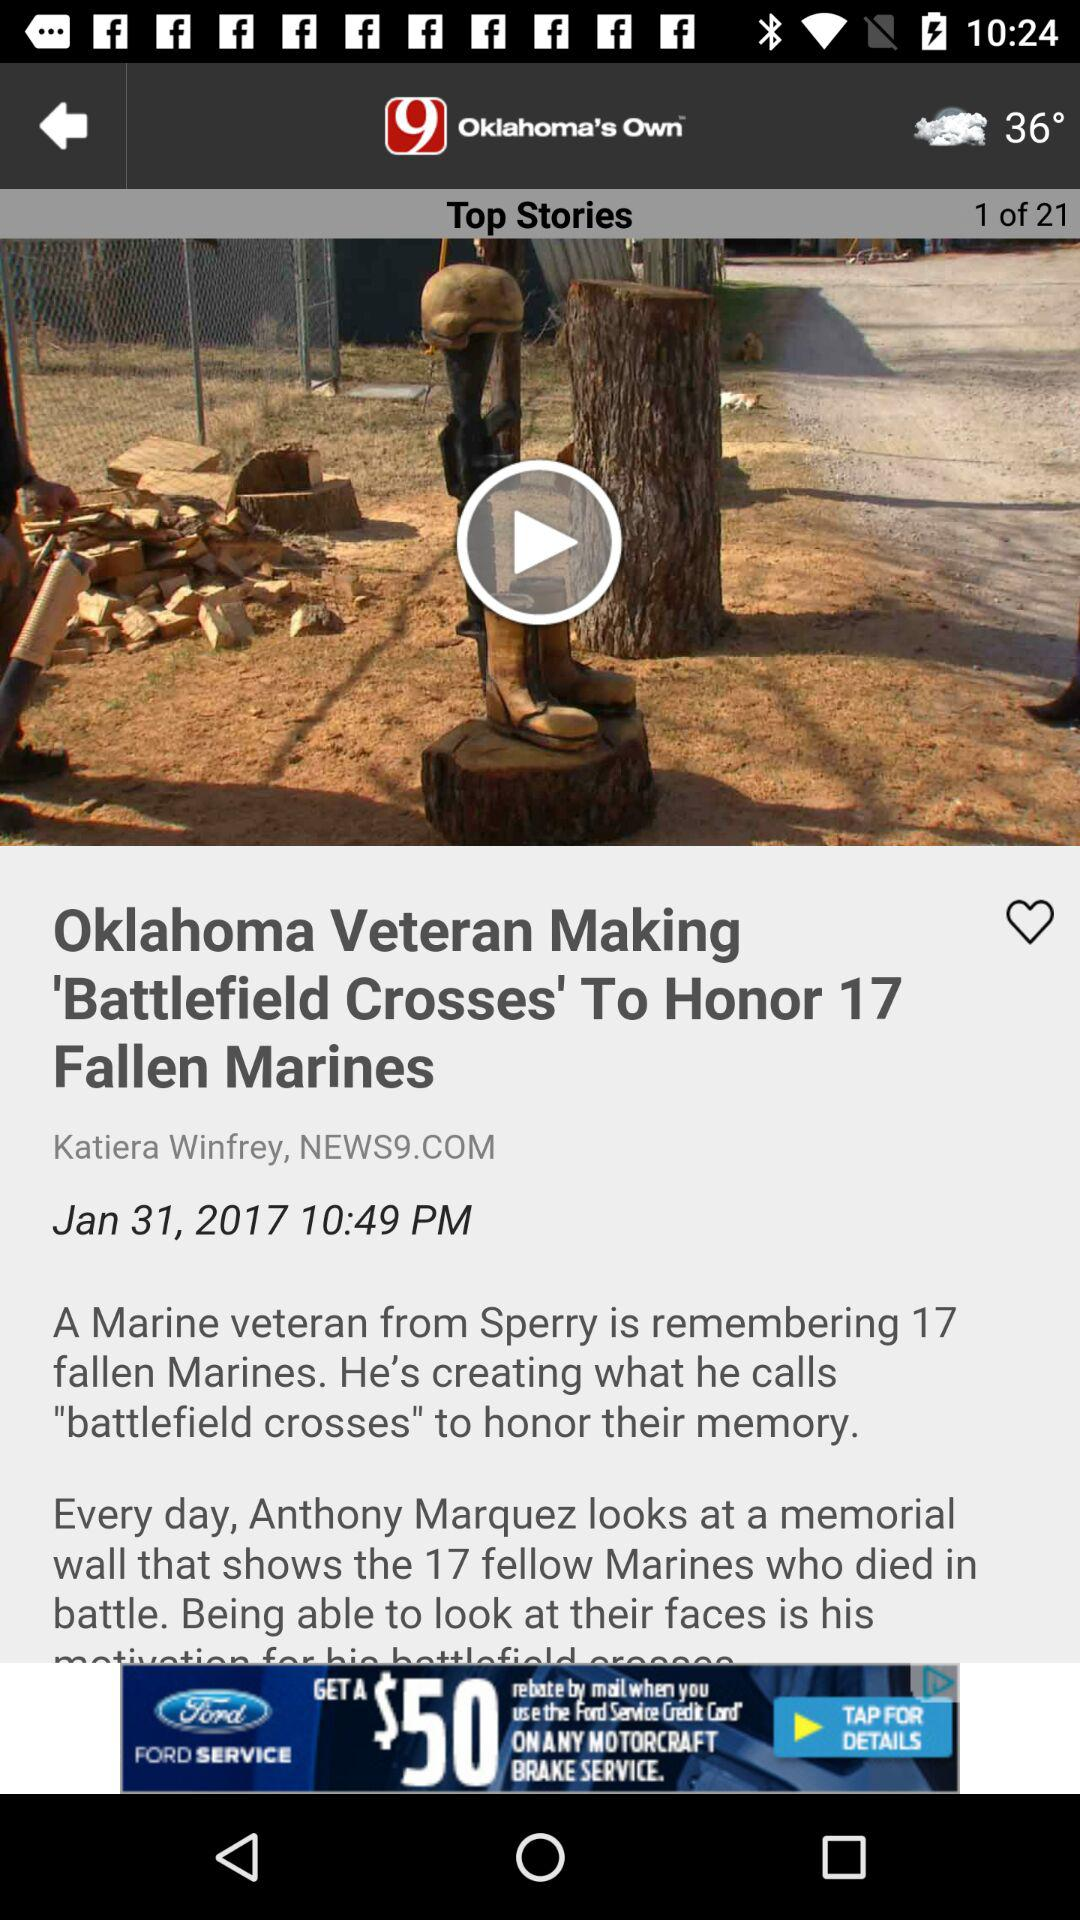What top story are we at right now? You are at top story 1. 